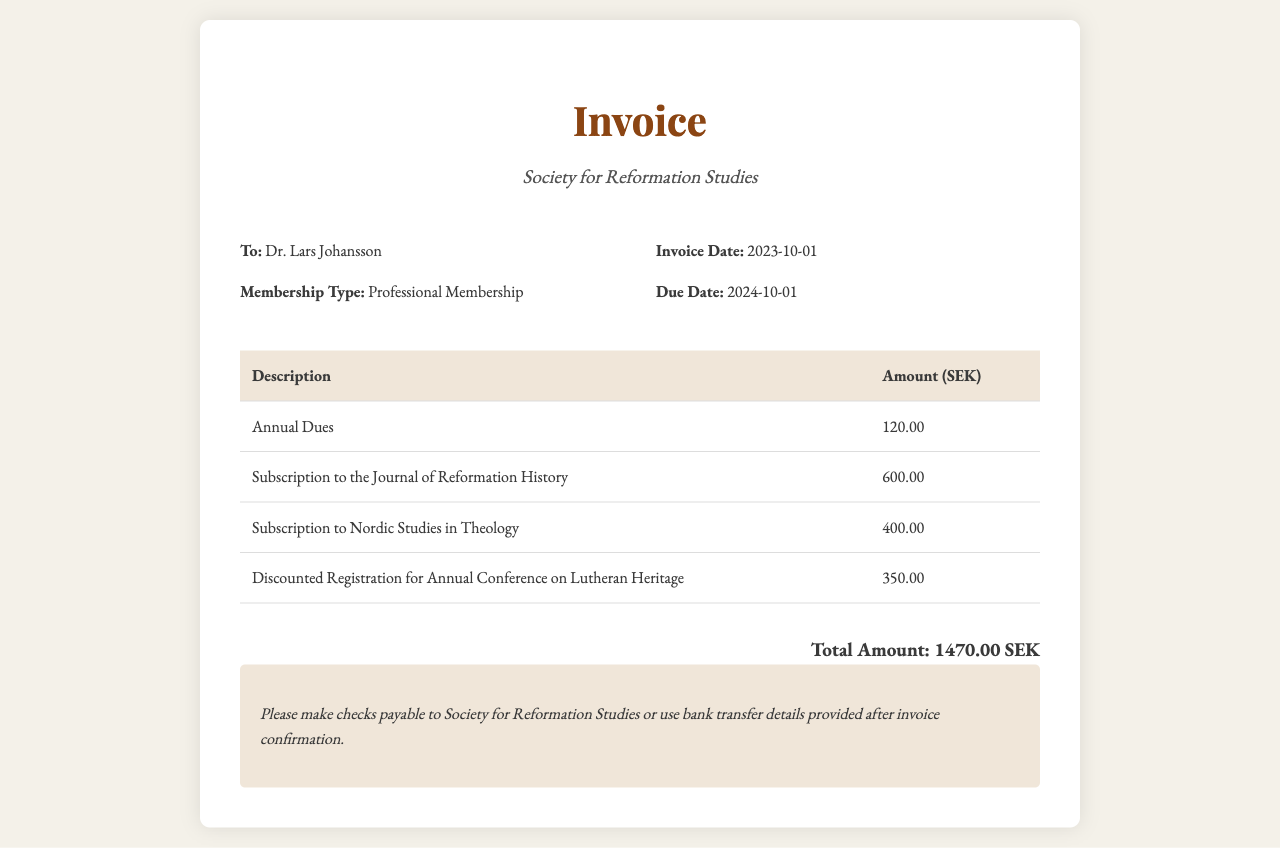What is the invoice date? The invoice date is specifically stated in the document, which is 2023-10-01.
Answer: 2023-10-01 What is the total amount due? The total amount due is aggregated from all items listed in the invoice, which totals 1470.00 SEK.
Answer: 1470.00 SEK Who is the invoice addressed to? The document specifies the recipient at the top, which is Dr. Lars Johansson.
Answer: Dr. Lars Johansson When is the due date for this invoice? The due date is clearly mentioned in the document as 2024-10-01.
Answer: 2024-10-01 What type of membership is being invoiced? The type of membership indicated on the invoice is Professional Membership.
Answer: Professional Membership How much is the subscription to the Journal of Reformation History? The document provides the amount for this subscription, which is 600.00 SEK.
Answer: 600.00 SEK What is the amount for the discounted conference registration? The invoice shows the amount for the discounted registration, which is 350.00 SEK.
Answer: 350.00 SEK How many subscriptions are listed in the invoice? The document lists two subscriptions: Journal of Reformation History and Nordic Studies in Theology, totaling two.
Answer: Two What payment methods are suggested? The document mentions making checks payable or using bank transfer after invoice confirmation.
Answer: Checks or bank transfer 